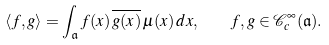<formula> <loc_0><loc_0><loc_500><loc_500>\langle f , g \rangle = \int _ { \mathfrak { a } } f ( x ) \, \overline { g ( x ) } \, \mu ( x ) \, d x , \quad f , g \in \mathcal { C } _ { c } ^ { \infty } ( \mathfrak { a } ) .</formula> 